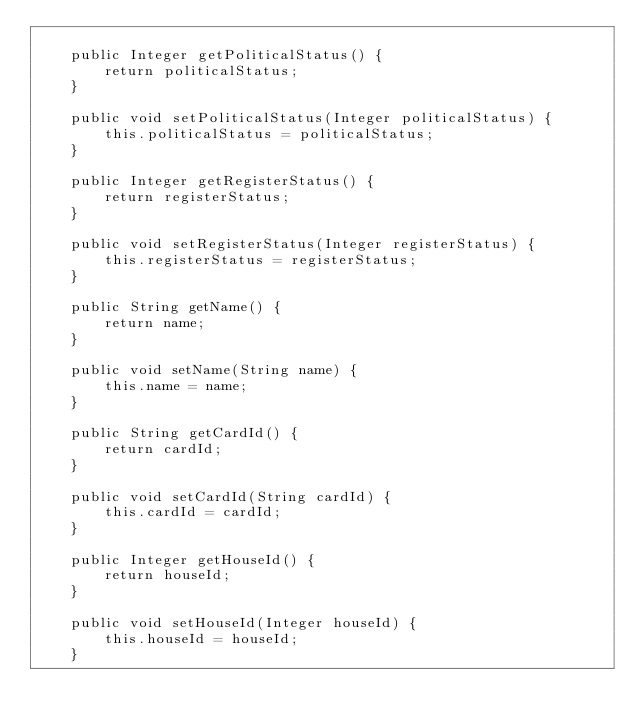<code> <loc_0><loc_0><loc_500><loc_500><_Java_>
    public Integer getPoliticalStatus() {
        return politicalStatus;
    }

    public void setPoliticalStatus(Integer politicalStatus) {
        this.politicalStatus = politicalStatus;
    }

    public Integer getRegisterStatus() {
        return registerStatus;
    }

    public void setRegisterStatus(Integer registerStatus) {
        this.registerStatus = registerStatus;
    }

    public String getName() {
        return name;
    }

    public void setName(String name) {
        this.name = name;
    }

    public String getCardId() {
        return cardId;
    }

    public void setCardId(String cardId) {
        this.cardId = cardId;
    }

    public Integer getHouseId() {
        return houseId;
    }

    public void setHouseId(Integer houseId) {
        this.houseId = houseId;
    }
</code> 